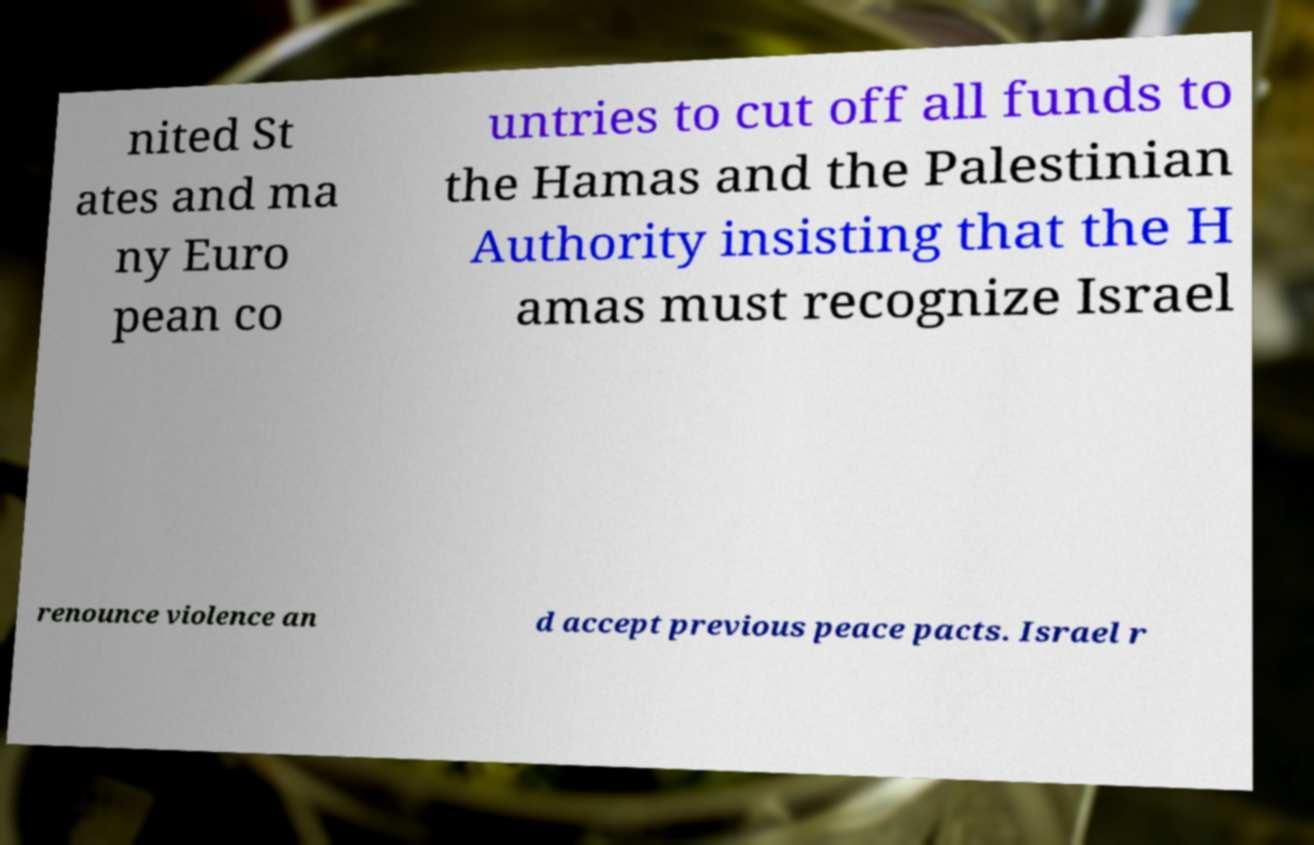Could you extract and type out the text from this image? nited St ates and ma ny Euro pean co untries to cut off all funds to the Hamas and the Palestinian Authority insisting that the H amas must recognize Israel renounce violence an d accept previous peace pacts. Israel r 